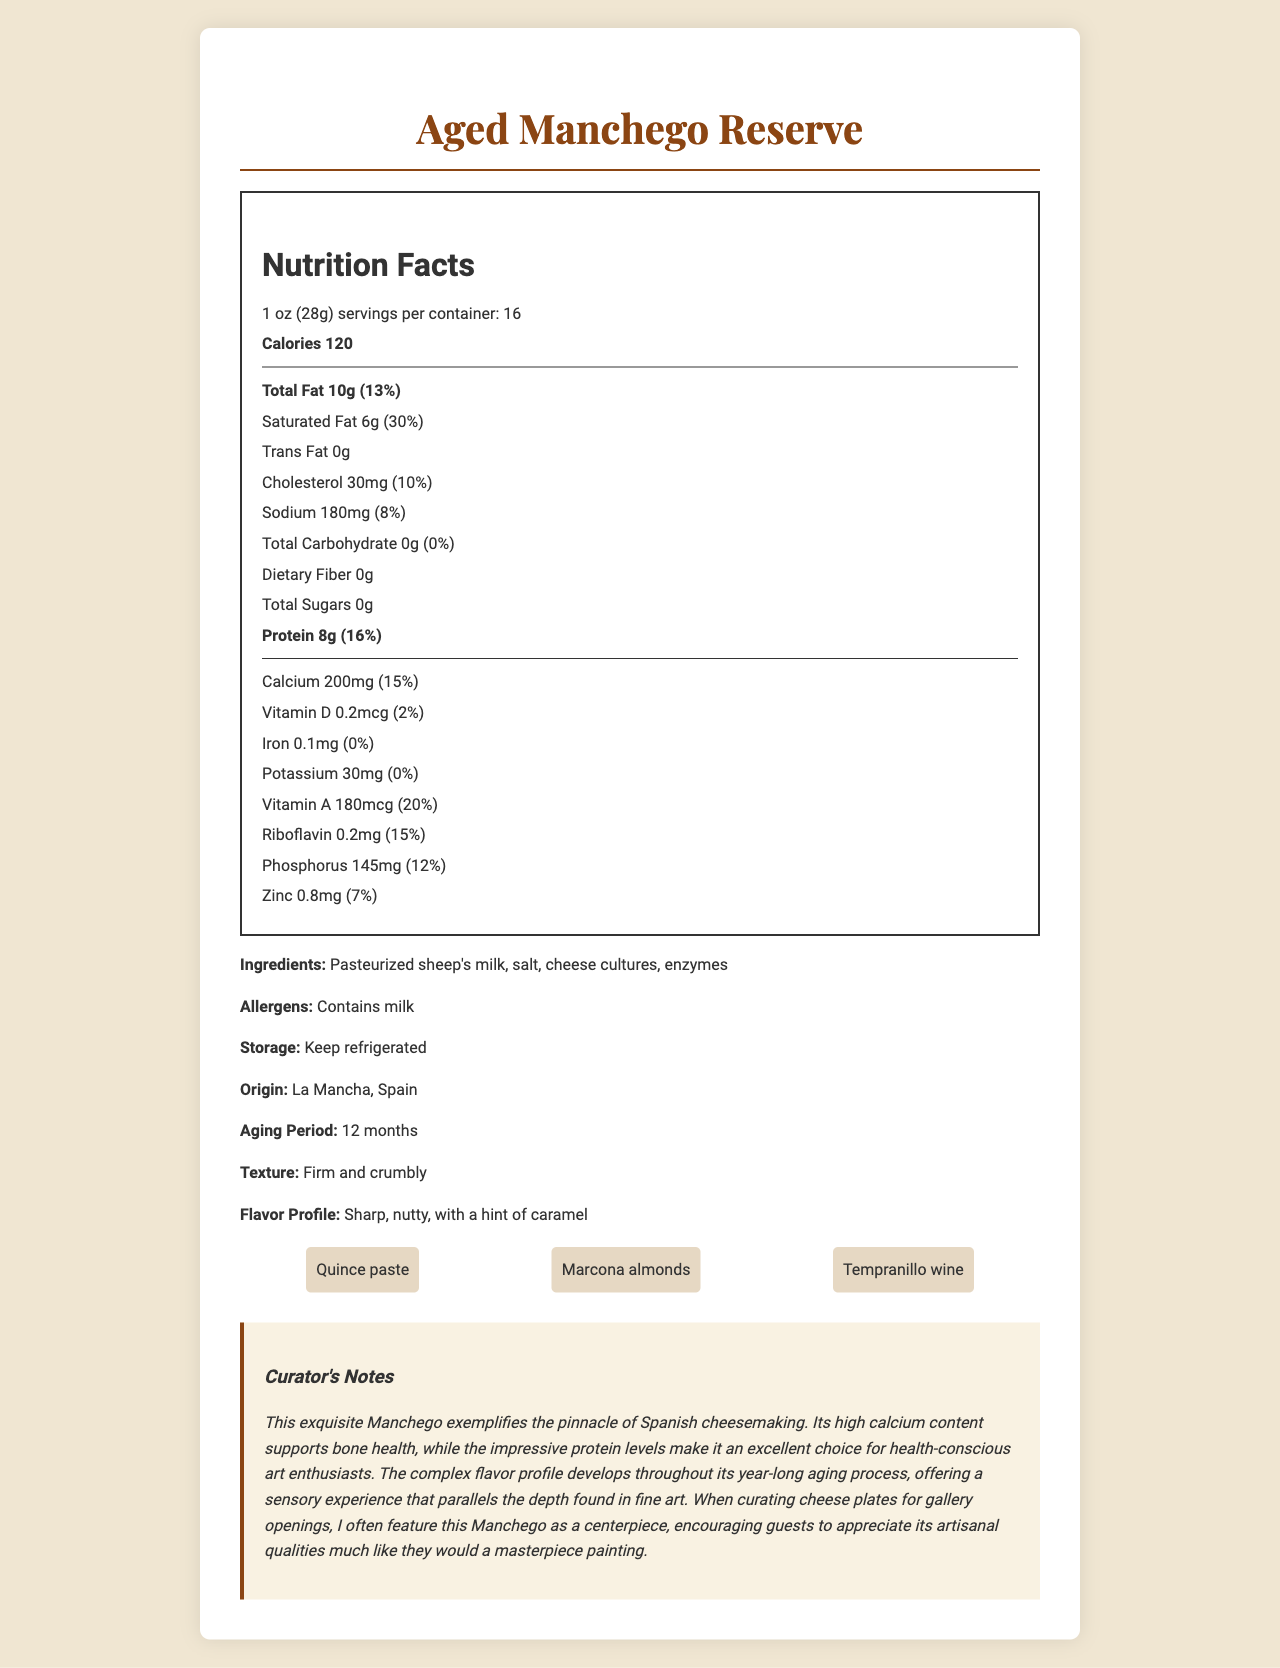how many servings are in the container? The label lists that there are 16 servings per container.
Answer: 16 what is the serving size? The document specifies the serving size as 1 oz (28g).
Answer: 1 oz (28g) how much protein is in one serving? The nutrition facts indicate that there are 8 grams of protein per serving.
Answer: 8g how much calcium is in one serving? According to the label, there are 200mg of calcium per serving.
Answer: 200mg what is the daily value percentage of saturated fat per serving? The nutrition facts show that the saturated fat content per serving is 30% of the daily value.
Answer: 30% where does the cheese originate from? The document states that the origin of the cheese is La Mancha, Spain.
Answer: La Mancha, Spain what is the aging period for this cheese? The document mentions that the aging period for the cheese is 12 months.
Answer: 12 months what are the pairing suggestions listed for this cheese? The pairing suggestions provided in the document include quince paste, Marcona almonds, and Tempranillo wine.
Answer: Quince paste, Marcona almonds, Tempranillo wine what are the major allergens in this cheese? The document lists milk as a major allergen.
Answer: Milk what vitamins and minerals are prominently listed with their daily value percentages? A. Vitamin C and Iron B. Calcium and Riboflavin C. Vitamin E and Zinc D. Vitamin B12 and Potassium The nutrition facts highlight that calcium has a daily value of 15%, and riboflavin has a daily value of 15%.
Answer: B. Calcium and Riboflavin which of the following best describes the flavor profile of the cheese? A. Sweet and tangy B. Sour and spicy C. Sharp, nutty, with a hint of caramel D. Bland and creamy The document describes the flavor profile as sharp, nutty, with a hint of caramel.
Answer: C. Sharp, nutty, with a hint of caramel is there any dietary fiber in this cheese? The nutrition facts indicate that there is 0g of dietary fiber per serving.
Answer: No can this cheese be stored at room temperature? The storage instructions specify that the cheese should be kept refrigerated.
Answer: No summarize the main points of this document. The document delivers a comprehensive overview of the nutritional content and attributes of the Aged Manchego Reserve cheese, backed by supportive notes for culinary and art appreciation contexts.
Answer: The document provides detailed nutrition facts, ingredients, and additional information about Aged Manchego Reserve cheese. It includes serving size, calorie content, breakdowns of fat, cholesterol, sodium, carbohydrate, protein, and various vitamins and minerals. The document also notes the cheese's origin, aging period, texture, flavor profile, allergens, and storage instructions. Curator notes emphasize the cheese's high calcium and protein content and its complex flavor profile. Pairing suggestions include quince paste, Marcona almonds, and Tempranillo wine, highlighting its artisanal qualities. what is the exact percentage of daily value for potassium? The document indicates the amount of potassium but does not state a daily value percentage for it.
Answer: Cannot be determined 